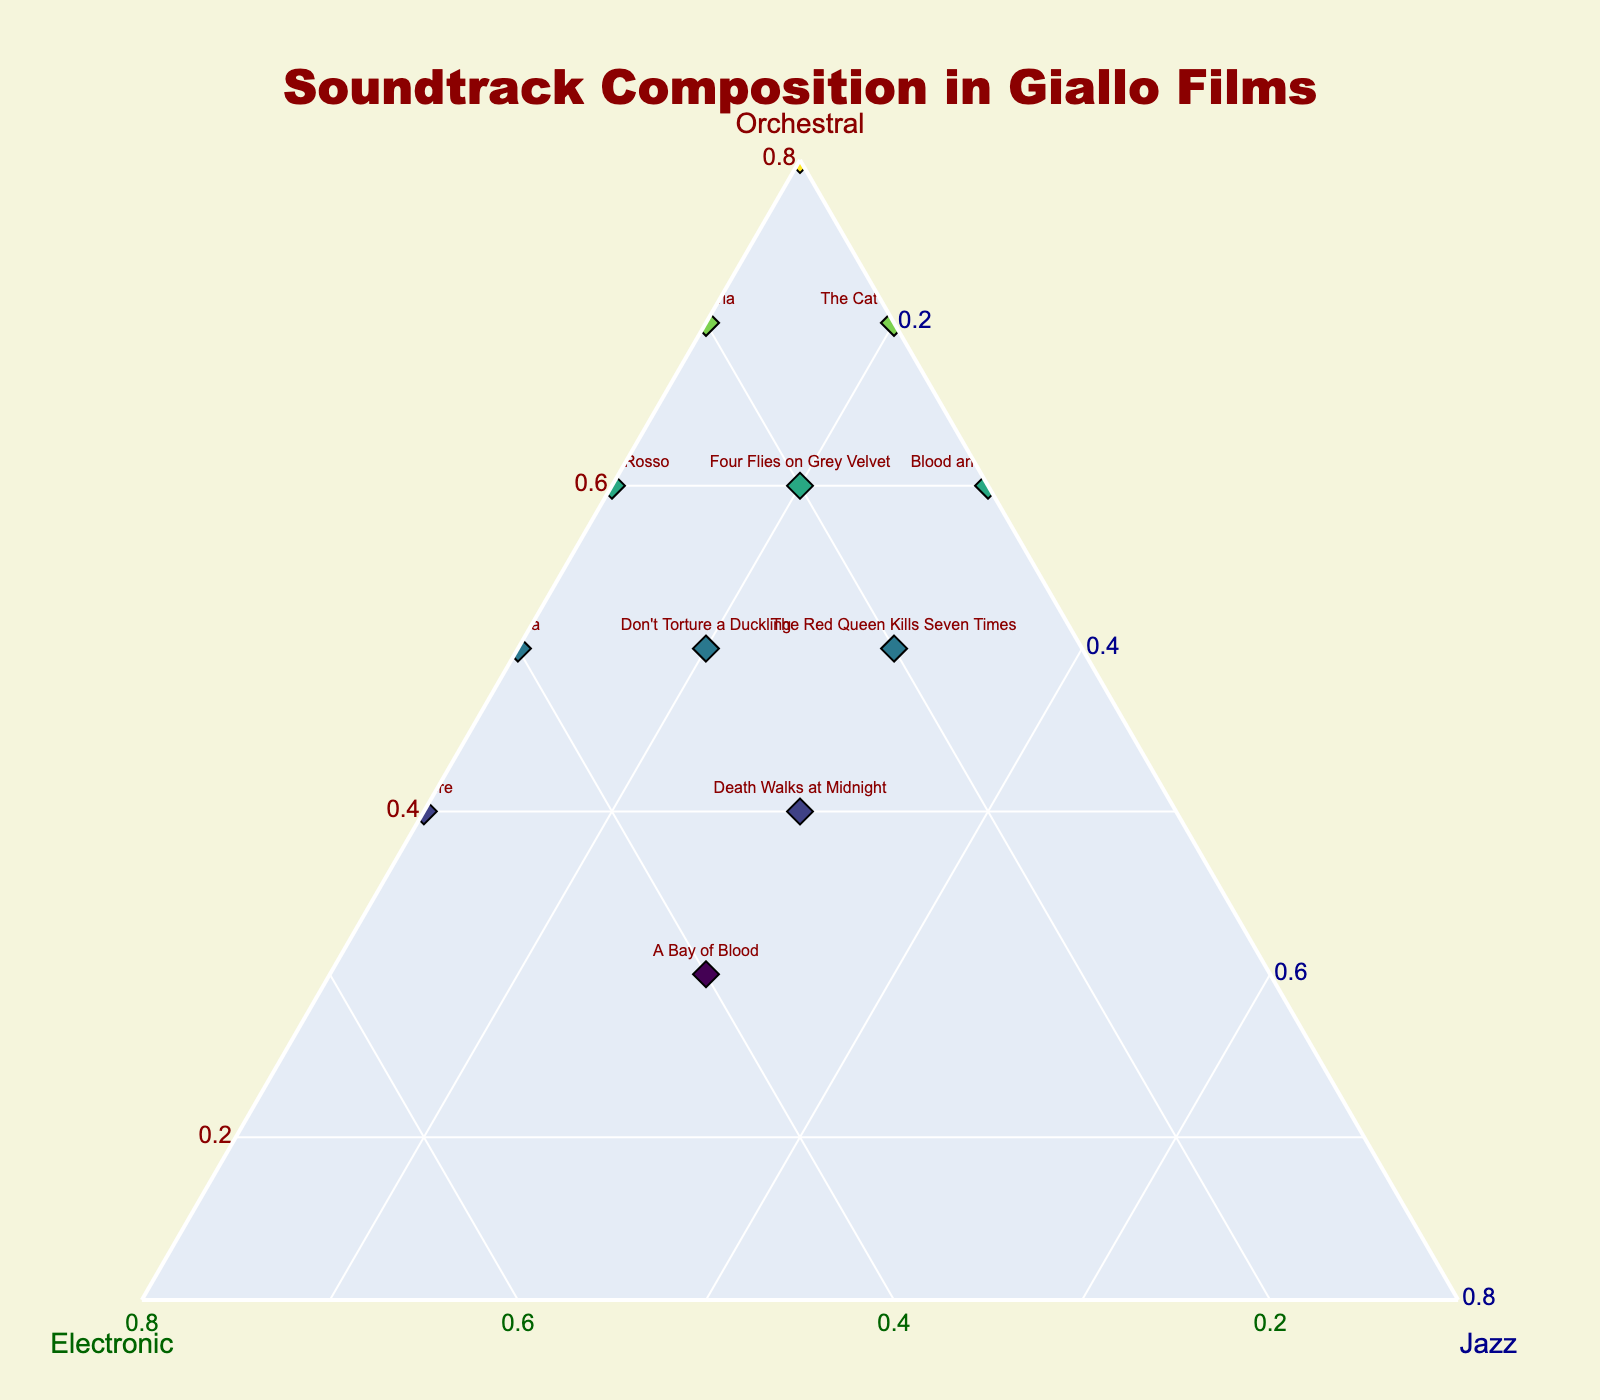What's the title of the plot? The title is typically located at the top of the plot. In this case, the title is "Soundtrack Composition in Giallo Films."
Answer: Soundtrack Composition in Giallo Films What axis represents the orchestral composition? Each axis is labeled with its corresponding component. The axis labeled "Orchestral" depicts orchestral composition.
Answer: Orchestral Which film has the highest orchestral composition? Look for the film closest to the “Orchestral” vertex of the ternary plot. The Bird with the Crystal Plumage is the nearest, indicating it has the highest orchestral composition.
Answer: The Bird with the Crystal Plumage Which films have the highest electronic influence? Look for films closest to the “Electronic” vertex of the ternary plot. Tenebre and Opera are near this vertex.
Answer: Tenebre, Opera Which film shows an equal composition of orchestral and electronic influence? Look for a point that is positioned equally between the "Orchestral" and "Electronic" vertices, suggesting near-equal influence. A Bay of Blood is closest to the line between orchestral and electronic, each roughly 0.4.
Answer: A Bay of Blood Which film shows the highest jazz influence? Look for the film closest to the "Jazz" vertex of the ternary plot. Blood and Black Lace is closest, indicating the highest jazz influence.
Answer: Blood and Black Lace Which films have an equal influence of jazz and orchestral components? Points near the line that divides the "Jazz" and "Orchestral" vertices equally indicate an equal influence. Death Walks at Midnight and The Red Queen Kills Seven Times have equal parts of jazz and orchestral (0.4 orchestral & 0.3 jazz for Death Walks at Midnight, 0.5 orchestral & 0.3 jazz for The Red Queen Kills Seven Times).
Answer: Death Walks at Midnight, The Red Queen Kills Seven Times Which film demonstrates a balanced composition of all three components? A point in the center of the ternary plot suggests a balanced composition. None of the films lie exactly in the center, but A Bay of Blood, with 0.3 orchestral, 0.4 electronic, and 0.3 jazz, is relatively balanced.
Answer: A Bay of Blood How many films have an orchestral composition of 0.6 or greater? Count the points near or above the 0.6 line on the orchestral axis. There are five films: Profondo Rosso, Suspiria, The Bird with the Crystal Plumage, Four Flies on Grey Velvet, The Cat o' Nine Tails.
Answer: Five What is the average electronic influence among all the films? Sum the electronic values and divide by the number of films: (0.3+0.2+0.5+0.4+0.1+0.2+0.1+0.3+0.1+0.2+0.3+0.4)/12 = 0.3.
Answer: 0.3 